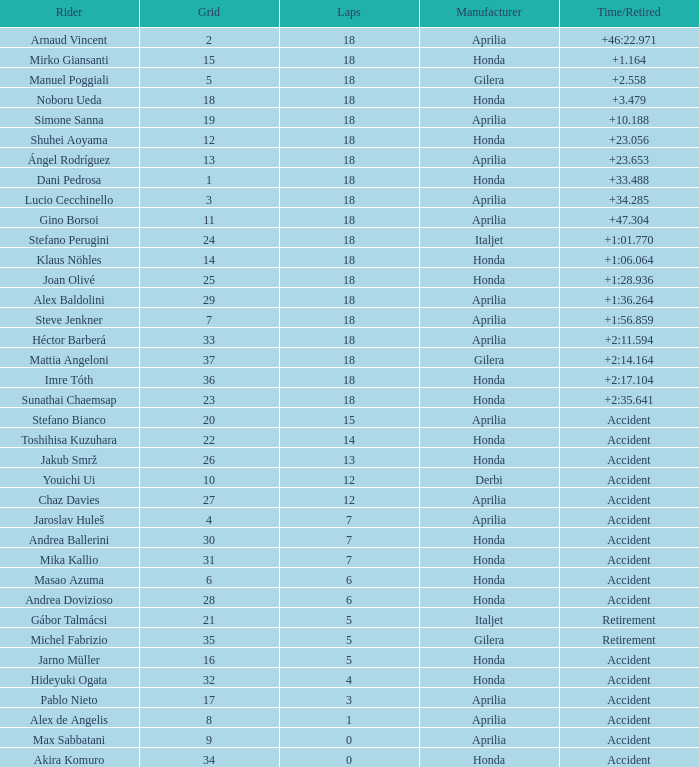What is the average number of laps with an accident time/retired, aprilia manufacturer and a grid of 27? 12.0. Could you parse the entire table as a dict? {'header': ['Rider', 'Grid', 'Laps', 'Manufacturer', 'Time/Retired'], 'rows': [['Arnaud Vincent', '2', '18', 'Aprilia', '+46:22.971'], ['Mirko Giansanti', '15', '18', 'Honda', '+1.164'], ['Manuel Poggiali', '5', '18', 'Gilera', '+2.558'], ['Noboru Ueda', '18', '18', 'Honda', '+3.479'], ['Simone Sanna', '19', '18', 'Aprilia', '+10.188'], ['Shuhei Aoyama', '12', '18', 'Honda', '+23.056'], ['Ángel Rodríguez', '13', '18', 'Aprilia', '+23.653'], ['Dani Pedrosa', '1', '18', 'Honda', '+33.488'], ['Lucio Cecchinello', '3', '18', 'Aprilia', '+34.285'], ['Gino Borsoi', '11', '18', 'Aprilia', '+47.304'], ['Stefano Perugini', '24', '18', 'Italjet', '+1:01.770'], ['Klaus Nöhles', '14', '18', 'Honda', '+1:06.064'], ['Joan Olivé', '25', '18', 'Honda', '+1:28.936'], ['Alex Baldolini', '29', '18', 'Aprilia', '+1:36.264'], ['Steve Jenkner', '7', '18', 'Aprilia', '+1:56.859'], ['Héctor Barberá', '33', '18', 'Aprilia', '+2:11.594'], ['Mattia Angeloni', '37', '18', 'Gilera', '+2:14.164'], ['Imre Tóth', '36', '18', 'Honda', '+2:17.104'], ['Sunathai Chaemsap', '23', '18', 'Honda', '+2:35.641'], ['Stefano Bianco', '20', '15', 'Aprilia', 'Accident'], ['Toshihisa Kuzuhara', '22', '14', 'Honda', 'Accident'], ['Jakub Smrž', '26', '13', 'Honda', 'Accident'], ['Youichi Ui', '10', '12', 'Derbi', 'Accident'], ['Chaz Davies', '27', '12', 'Aprilia', 'Accident'], ['Jaroslav Huleš', '4', '7', 'Aprilia', 'Accident'], ['Andrea Ballerini', '30', '7', 'Honda', 'Accident'], ['Mika Kallio', '31', '7', 'Honda', 'Accident'], ['Masao Azuma', '6', '6', 'Honda', 'Accident'], ['Andrea Dovizioso', '28', '6', 'Honda', 'Accident'], ['Gábor Talmácsi', '21', '5', 'Italjet', 'Retirement'], ['Michel Fabrizio', '35', '5', 'Gilera', 'Retirement'], ['Jarno Müller', '16', '5', 'Honda', 'Accident'], ['Hideyuki Ogata', '32', '4', 'Honda', 'Accident'], ['Pablo Nieto', '17', '3', 'Aprilia', 'Accident'], ['Alex de Angelis', '8', '1', 'Aprilia', 'Accident'], ['Max Sabbatani', '9', '0', 'Aprilia', 'Accident'], ['Akira Komuro', '34', '0', 'Honda', 'Accident']]} 